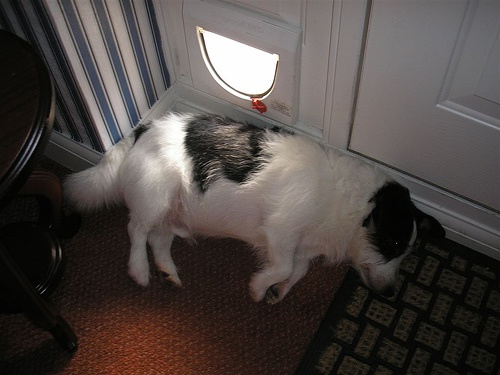Describe the objects in this image and their specific colors. I can see a dog in black, gray, and darkgray tones in this image. 